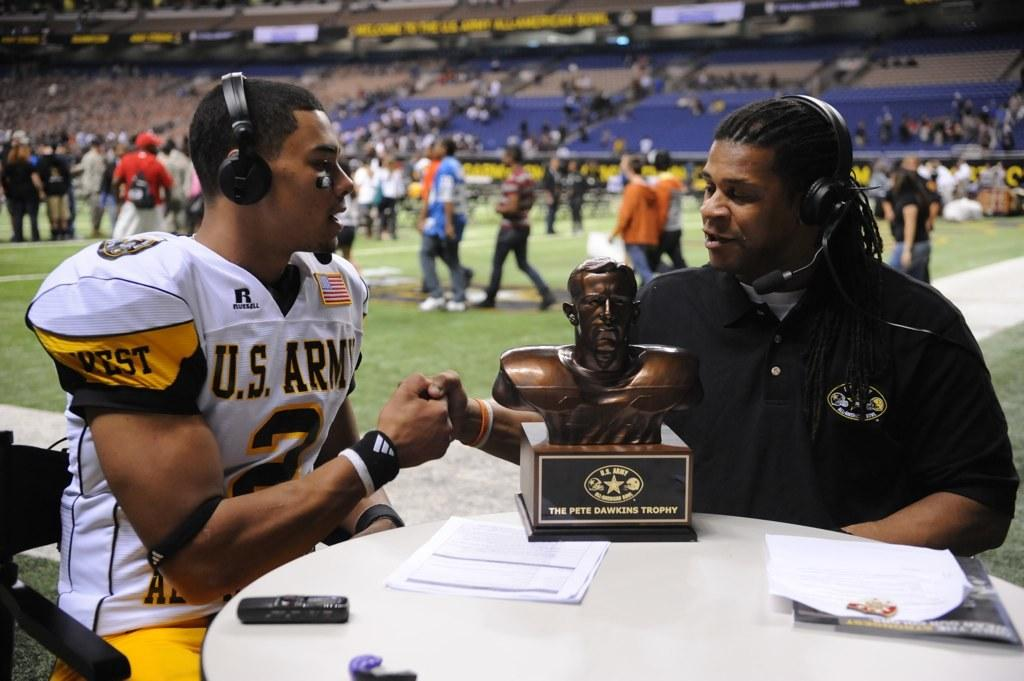What type of structure is visible in the image? There is a stadium in the image. How many people can be seen in the image? There are many people in the image. Can you describe the seating arrangement of two people in the image? There are two people sitting on chairs in the image. What is the significance of the trophy in the image? The presence of a trophy suggests that there might be an event or competition taking place. What other objects are present on the table besides the trophy? There are other objects on the table in the image. How many parents are visible in the image? There is no mention of parents in the image, so it is not possible to determine their presence or number. 